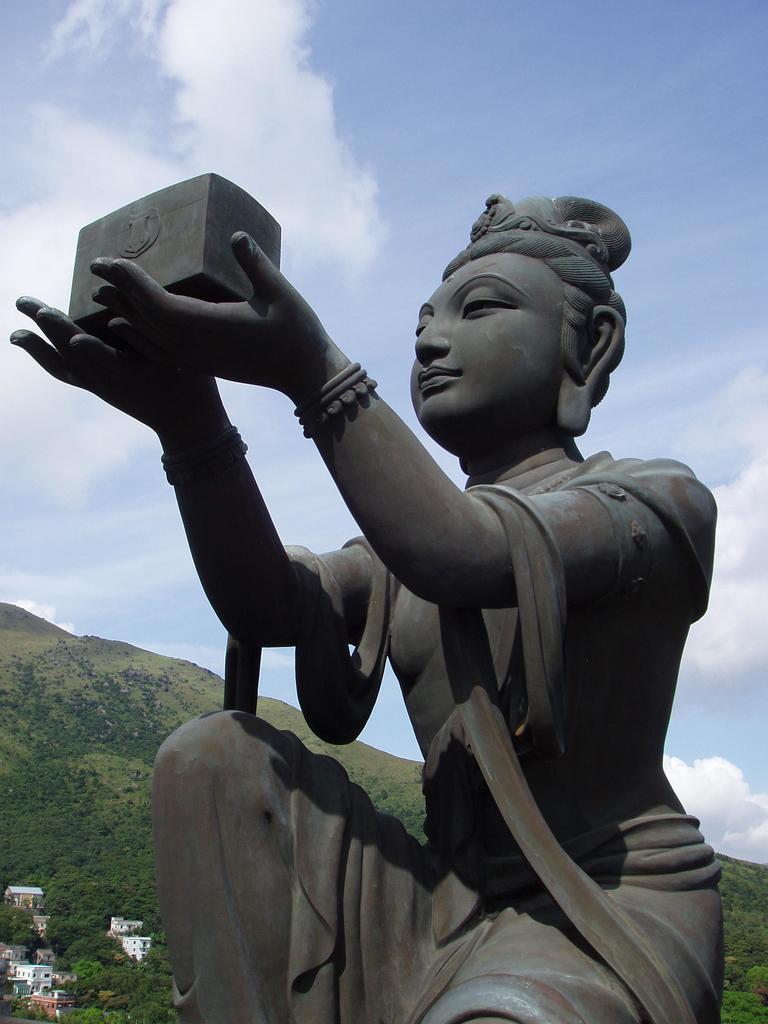What is the main subject of the image? There is a statue of a woman in the image. How is the woman depicted in the statue? The woman is in a squat position. What is the woman holding in her hands? The woman is holding an object in her hands. What can be seen in the background of the image? There are buildings, trees, mountains, and clouds in the sky in the background of the image. How many birds are in the flock flying over the mountains in the image? There is no flock of birds visible in the image; it features a statue of a woman and various elements in the background. 